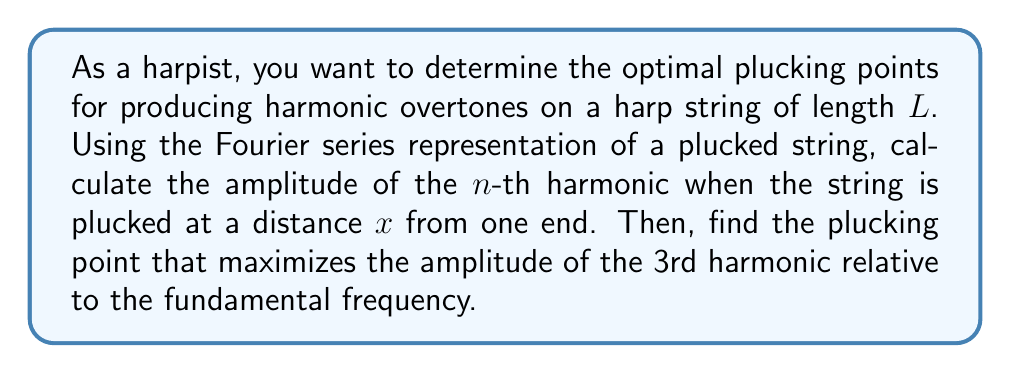Can you solve this math problem? To solve this problem, we'll follow these steps:

1) The displacement of a plucked string can be represented by a Fourier series:

   $$y(x,t) = \sum_{n=1}^{\infty} A_n \sin(\frac{n\pi x}{L}) \cos(\frac{n\pi c t}{L})$$

   where $A_n$ is the amplitude of the $n$-th harmonic, $c$ is the wave speed, and $L$ is the string length.

2) For a string plucked at position $a$, the amplitude $A_n$ is given by:

   $$A_n = \frac{4h}{n^2\pi^2} \sin(\frac{n\pi a}{L})$$

   where $h$ is the initial displacement at the plucking point.

3) To maximize the amplitude of the 3rd harmonic relative to the fundamental, we need to maximize the ratio:

   $$\frac{A_3}{A_1} = \frac{\sin(\frac{3\pi a}{L})}{9\sin(\frac{\pi a}{L})}$$

4) To find the maximum, we can differentiate this ratio with respect to $a$ and set it to zero:

   $$\frac{d}{da}(\frac{A_3}{A_1}) = \frac{3\pi}{L} \cdot \frac{9\cos(\frac{3\pi a}{L})\sin(\frac{\pi a}{L}) - \cos(\frac{\pi a}{L})\sin(\frac{3\pi a}{L})}{81\sin^2(\frac{\pi a}{L})} = 0$$

5) This equation is satisfied when:

   $$9\cos(\frac{3\pi a}{L})\sin(\frac{\pi a}{L}) = \cos(\frac{\pi a}{L})\sin(\frac{3\pi a}{L})$$

6) Using trigonometric identities, we can simplify this to:

   $$\sin(\frac{2\pi a}{L}) = 0$$

7) The solutions to this equation are:

   $$\frac{2\pi a}{L} = n\pi, \quad n = 0, 1, 2, ...$$

8) The non-trivial solutions within the string length are:

   $$a = \frac{L}{2}, \frac{L}{4}, \frac{3L}{4}$$

9) Among these, $\frac{L}{4}$ and $\frac{3L}{4}$ maximize the ratio $\frac{A_3}{A_1}$.
Answer: The optimal plucking points to maximize the 3rd harmonic relative to the fundamental are at $\frac{1}{4}$ and $\frac{3}{4}$ of the string length from either end. 